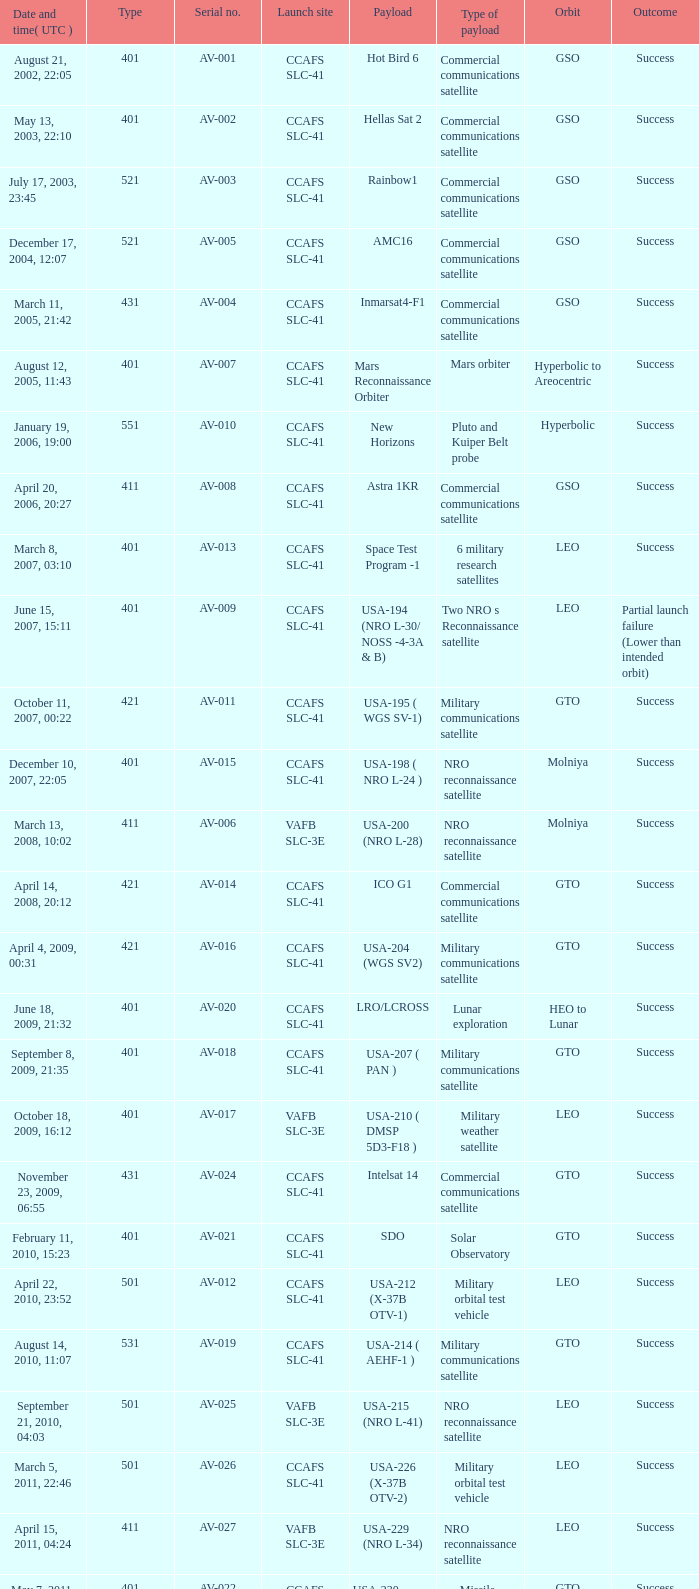On november 26, 2011, at 15:02, what payload was present? Mars rover. 